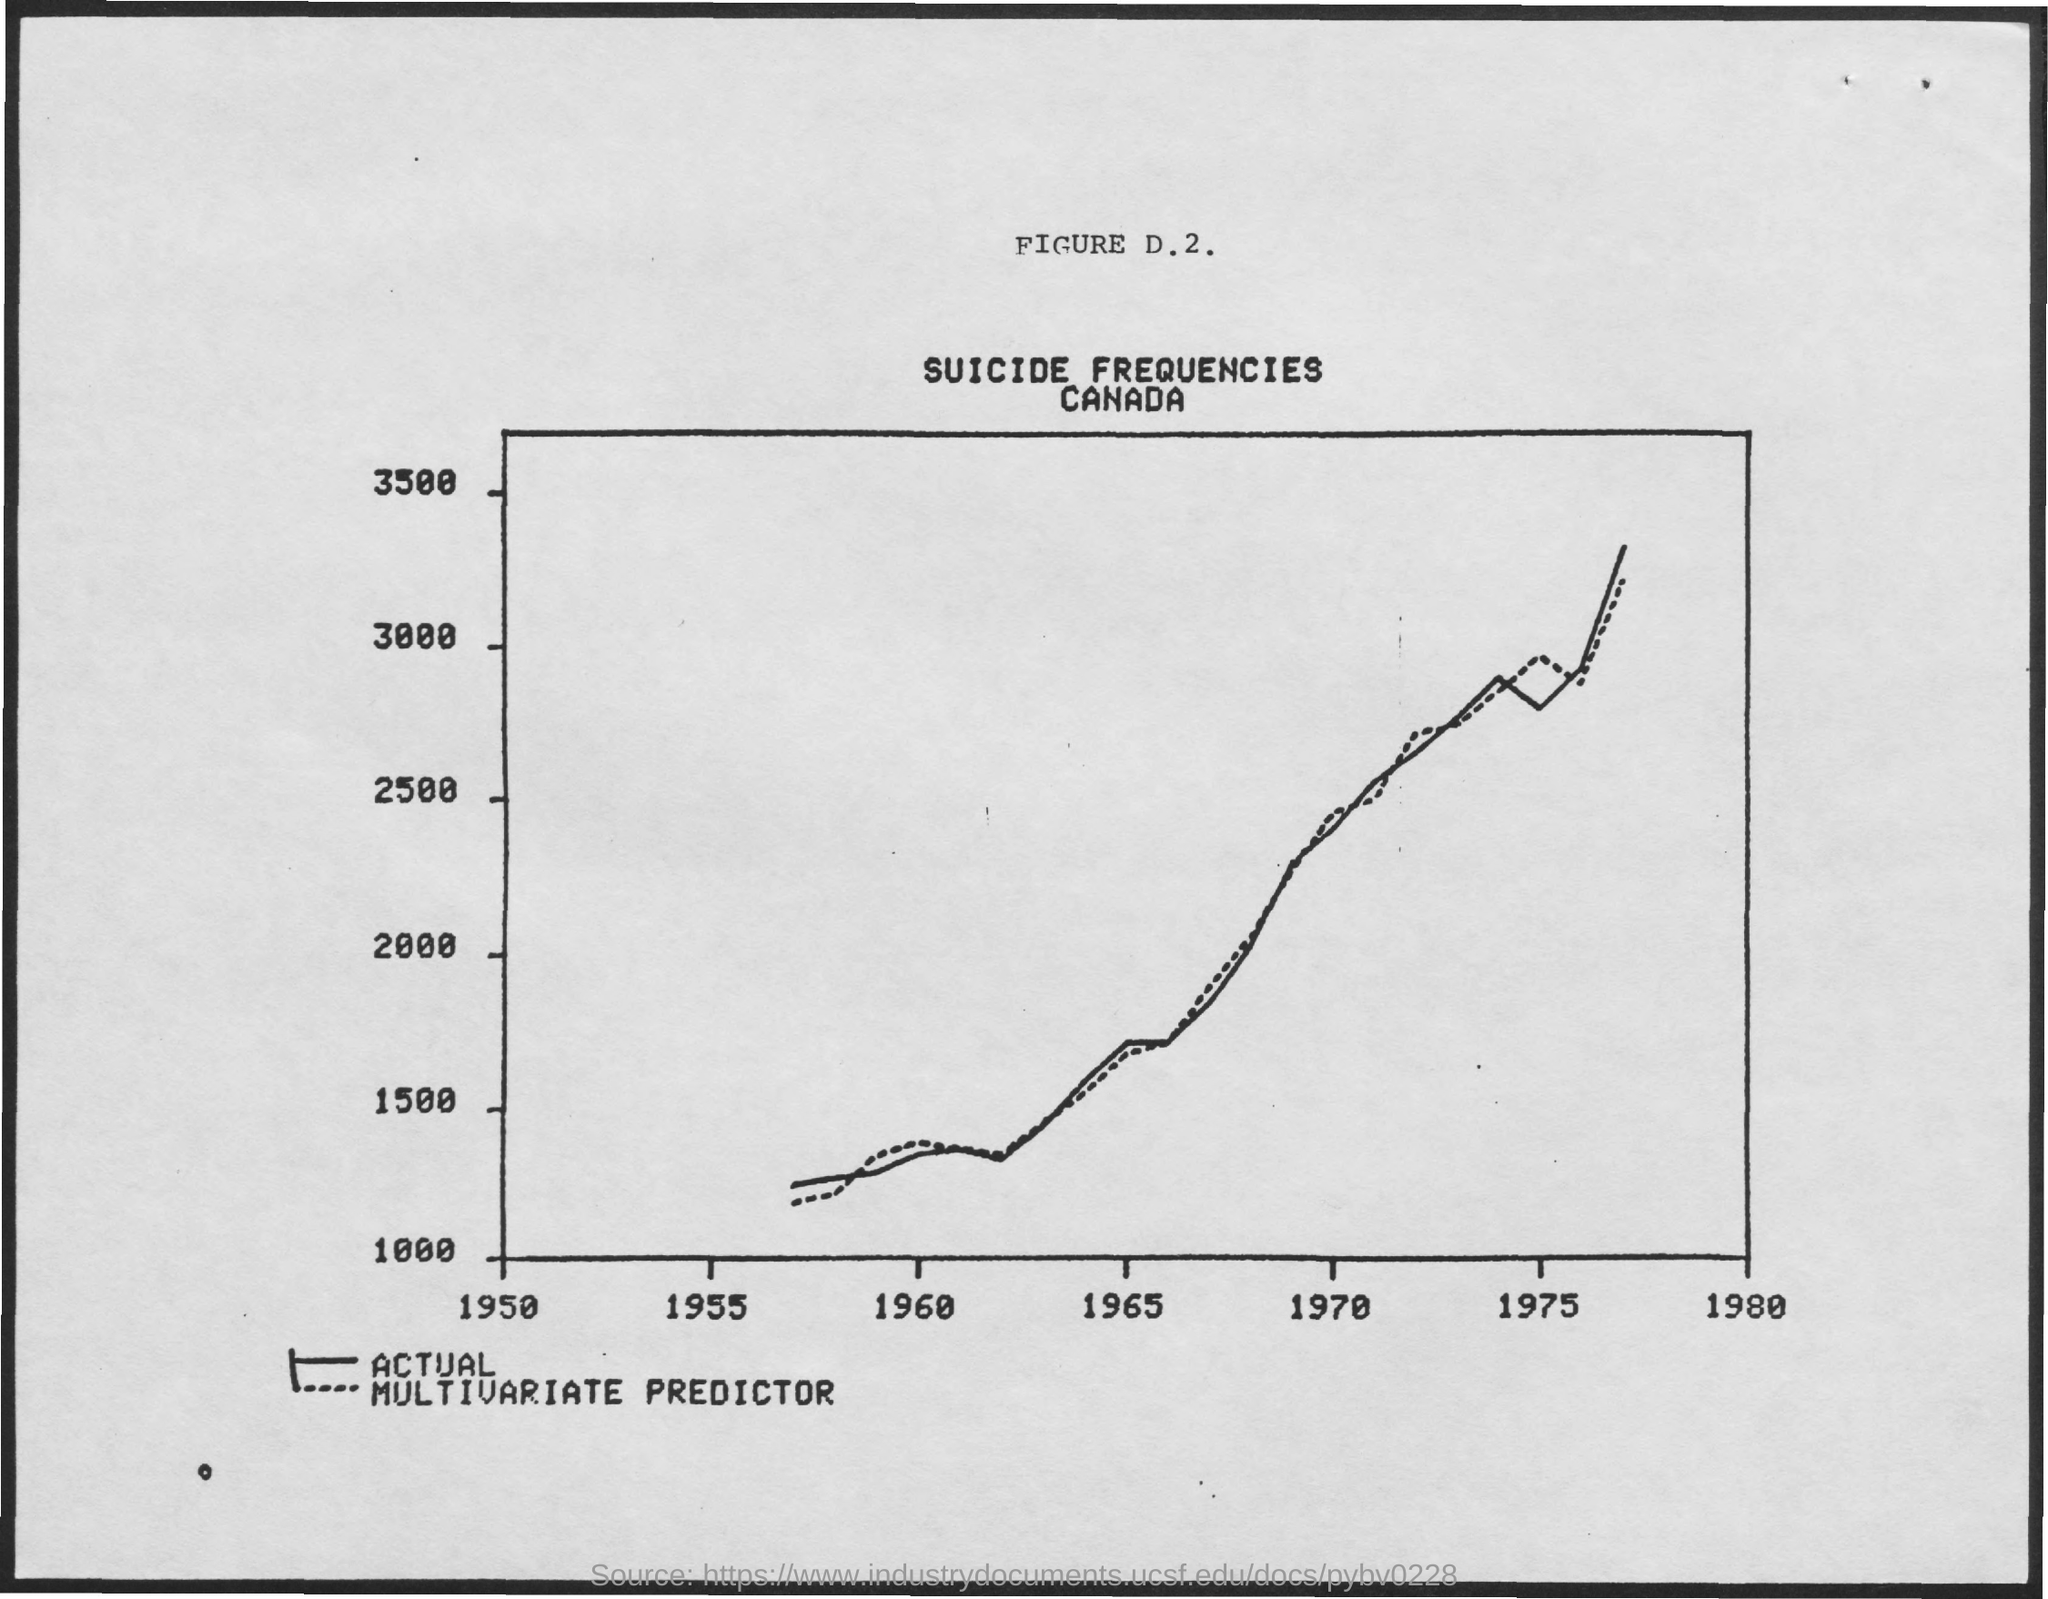What is the figure number mentioned ?
Offer a very short reply. D.2. What is the title of the graph
Your response must be concise. Suicide frequencies canada. 